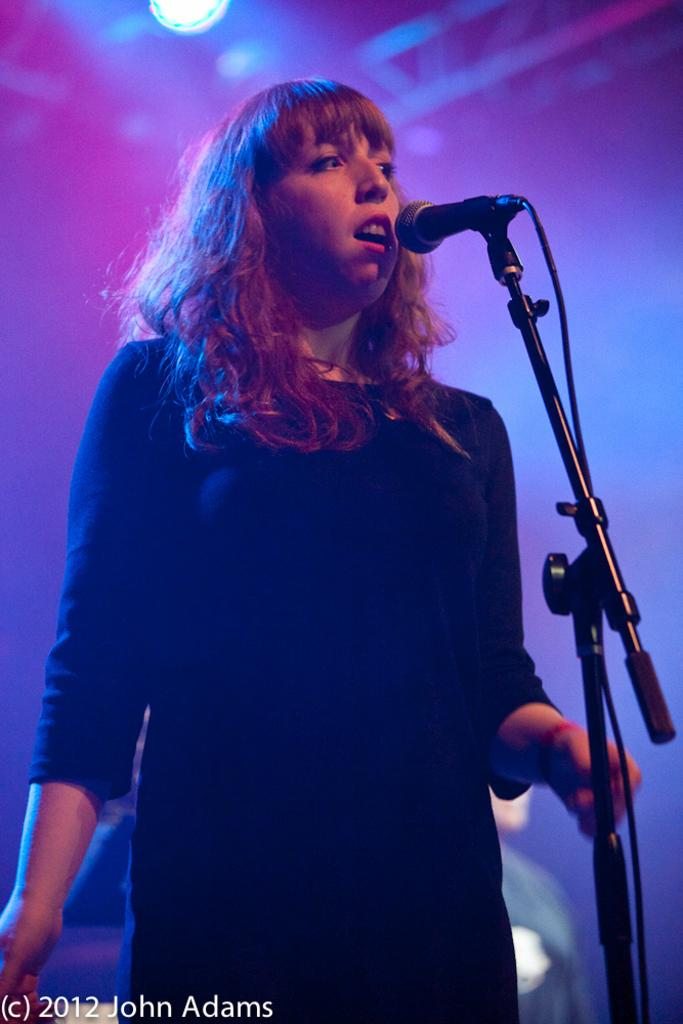What is there is a lady standing in front of a mic, what is she doing? The lady is standing in front of a mic, which suggests she might be singing, speaking, or performing. What can be found in the bottom left corner of the image? There is text in the bottom left of the image. What type of illumination is present at the top of the image? There is light at the top of the image. What type of stone can be seen rolling in the image? There is no stone or rolling object present in the image. 